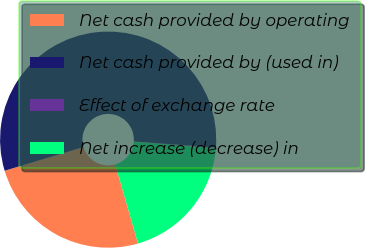Convert chart to OTSL. <chart><loc_0><loc_0><loc_500><loc_500><pie_chart><fcel>Net cash provided by operating<fcel>Net cash provided by (used in)<fcel>Effect of exchange rate<fcel>Net increase (decrease) in<nl><fcel>24.81%<fcel>55.81%<fcel>0.14%<fcel>19.24%<nl></chart> 